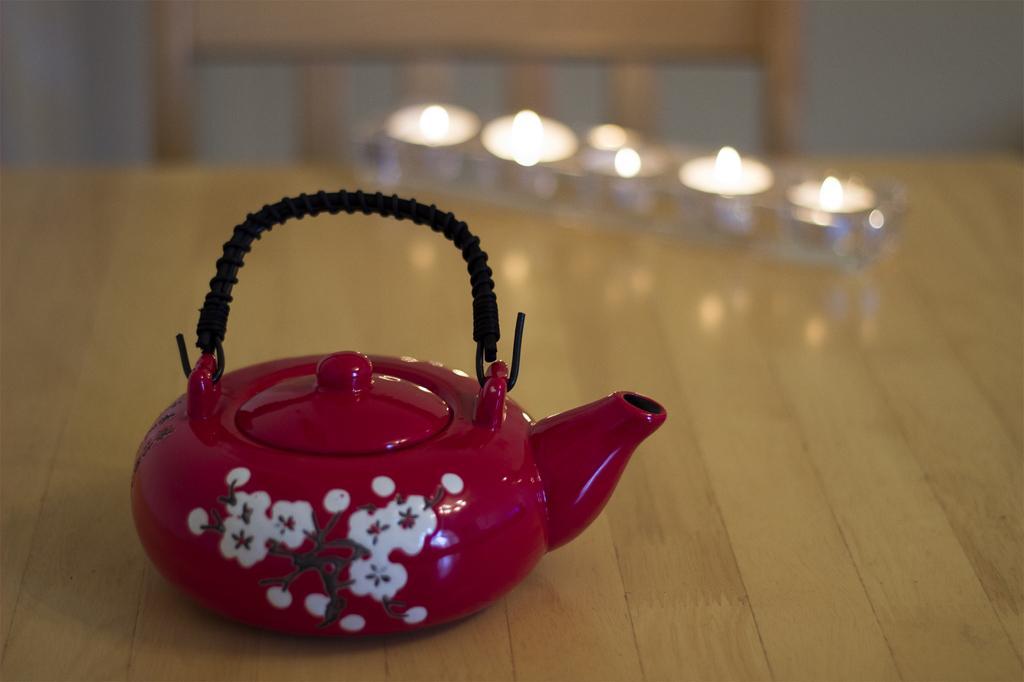How would you summarize this image in a sentence or two? In this picture we can see a teapot, lighted candles on the table, chair and in the background it is blur. 